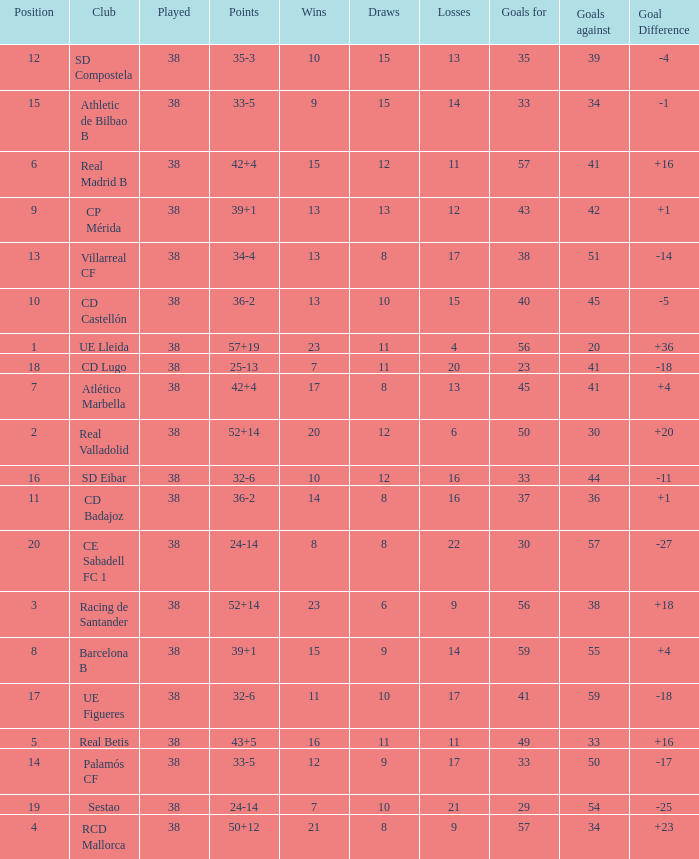What is the highest number of wins with a goal difference less than 4 at the Villarreal CF and more than 38 played? None. 